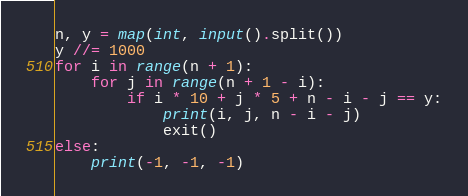<code> <loc_0><loc_0><loc_500><loc_500><_Python_>n, y = map(int, input().split())
y //= 1000
for i in range(n + 1):
    for j in range(n + 1 - i):
        if i * 10 + j * 5 + n - i - j == y:
            print(i, j, n - i - j)
            exit()
else:
    print(-1, -1, -1)</code> 